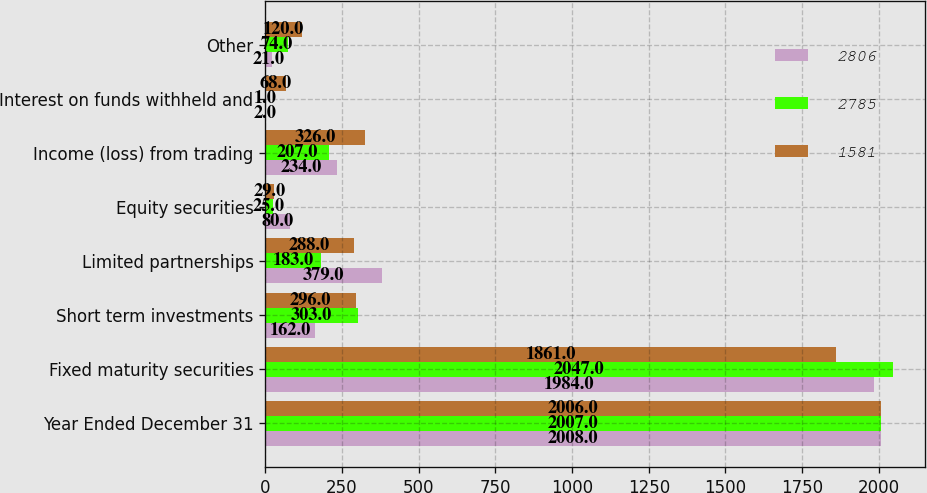<chart> <loc_0><loc_0><loc_500><loc_500><stacked_bar_chart><ecel><fcel>Year Ended December 31<fcel>Fixed maturity securities<fcel>Short term investments<fcel>Limited partnerships<fcel>Equity securities<fcel>Income (loss) from trading<fcel>Interest on funds withheld and<fcel>Other<nl><fcel>2806<fcel>2008<fcel>1984<fcel>162<fcel>379<fcel>80<fcel>234<fcel>2<fcel>21<nl><fcel>2785<fcel>2007<fcel>2047<fcel>303<fcel>183<fcel>25<fcel>207<fcel>1<fcel>74<nl><fcel>1581<fcel>2006<fcel>1861<fcel>296<fcel>288<fcel>29<fcel>326<fcel>68<fcel>120<nl></chart> 